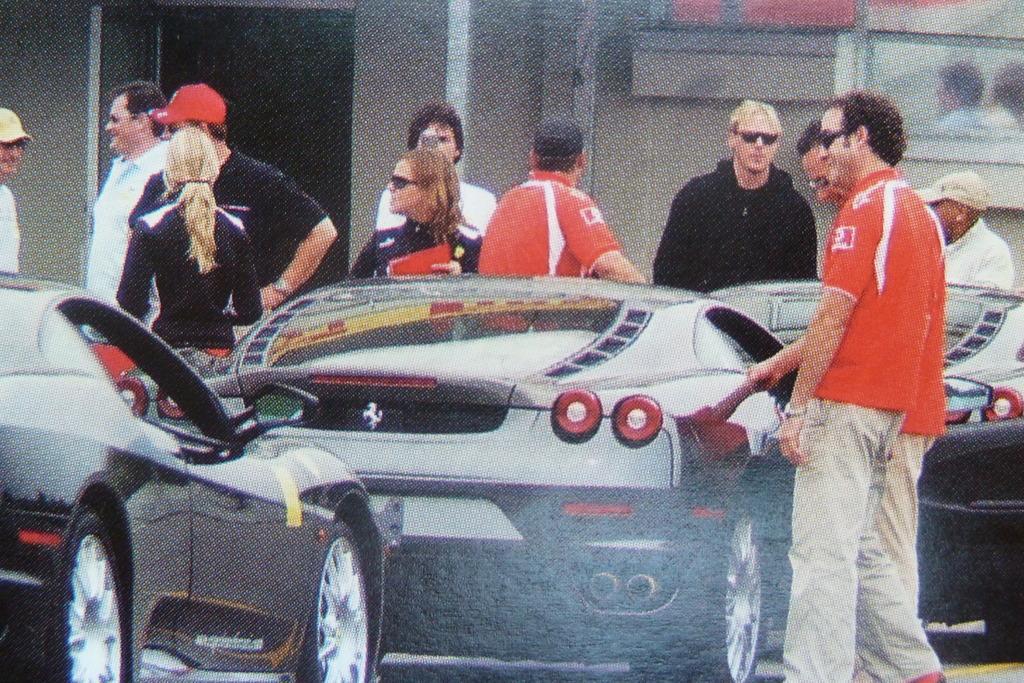How would you summarize this image in a sentence or two? In this picture we can see cars and a group of people standing on the ground were some of them wore goggles and caps and in the background we can see the wall, glass. 